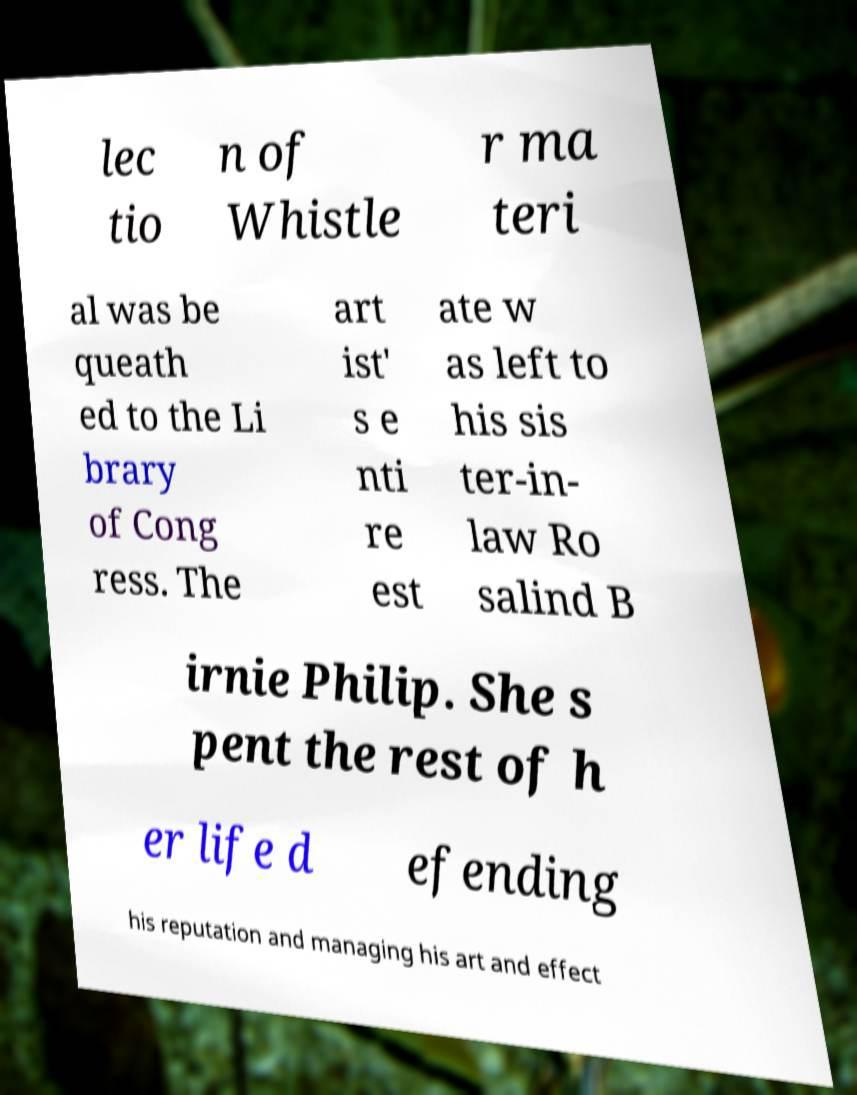Please identify and transcribe the text found in this image. lec tio n of Whistle r ma teri al was be queath ed to the Li brary of Cong ress. The art ist' s e nti re est ate w as left to his sis ter-in- law Ro salind B irnie Philip. She s pent the rest of h er life d efending his reputation and managing his art and effect 